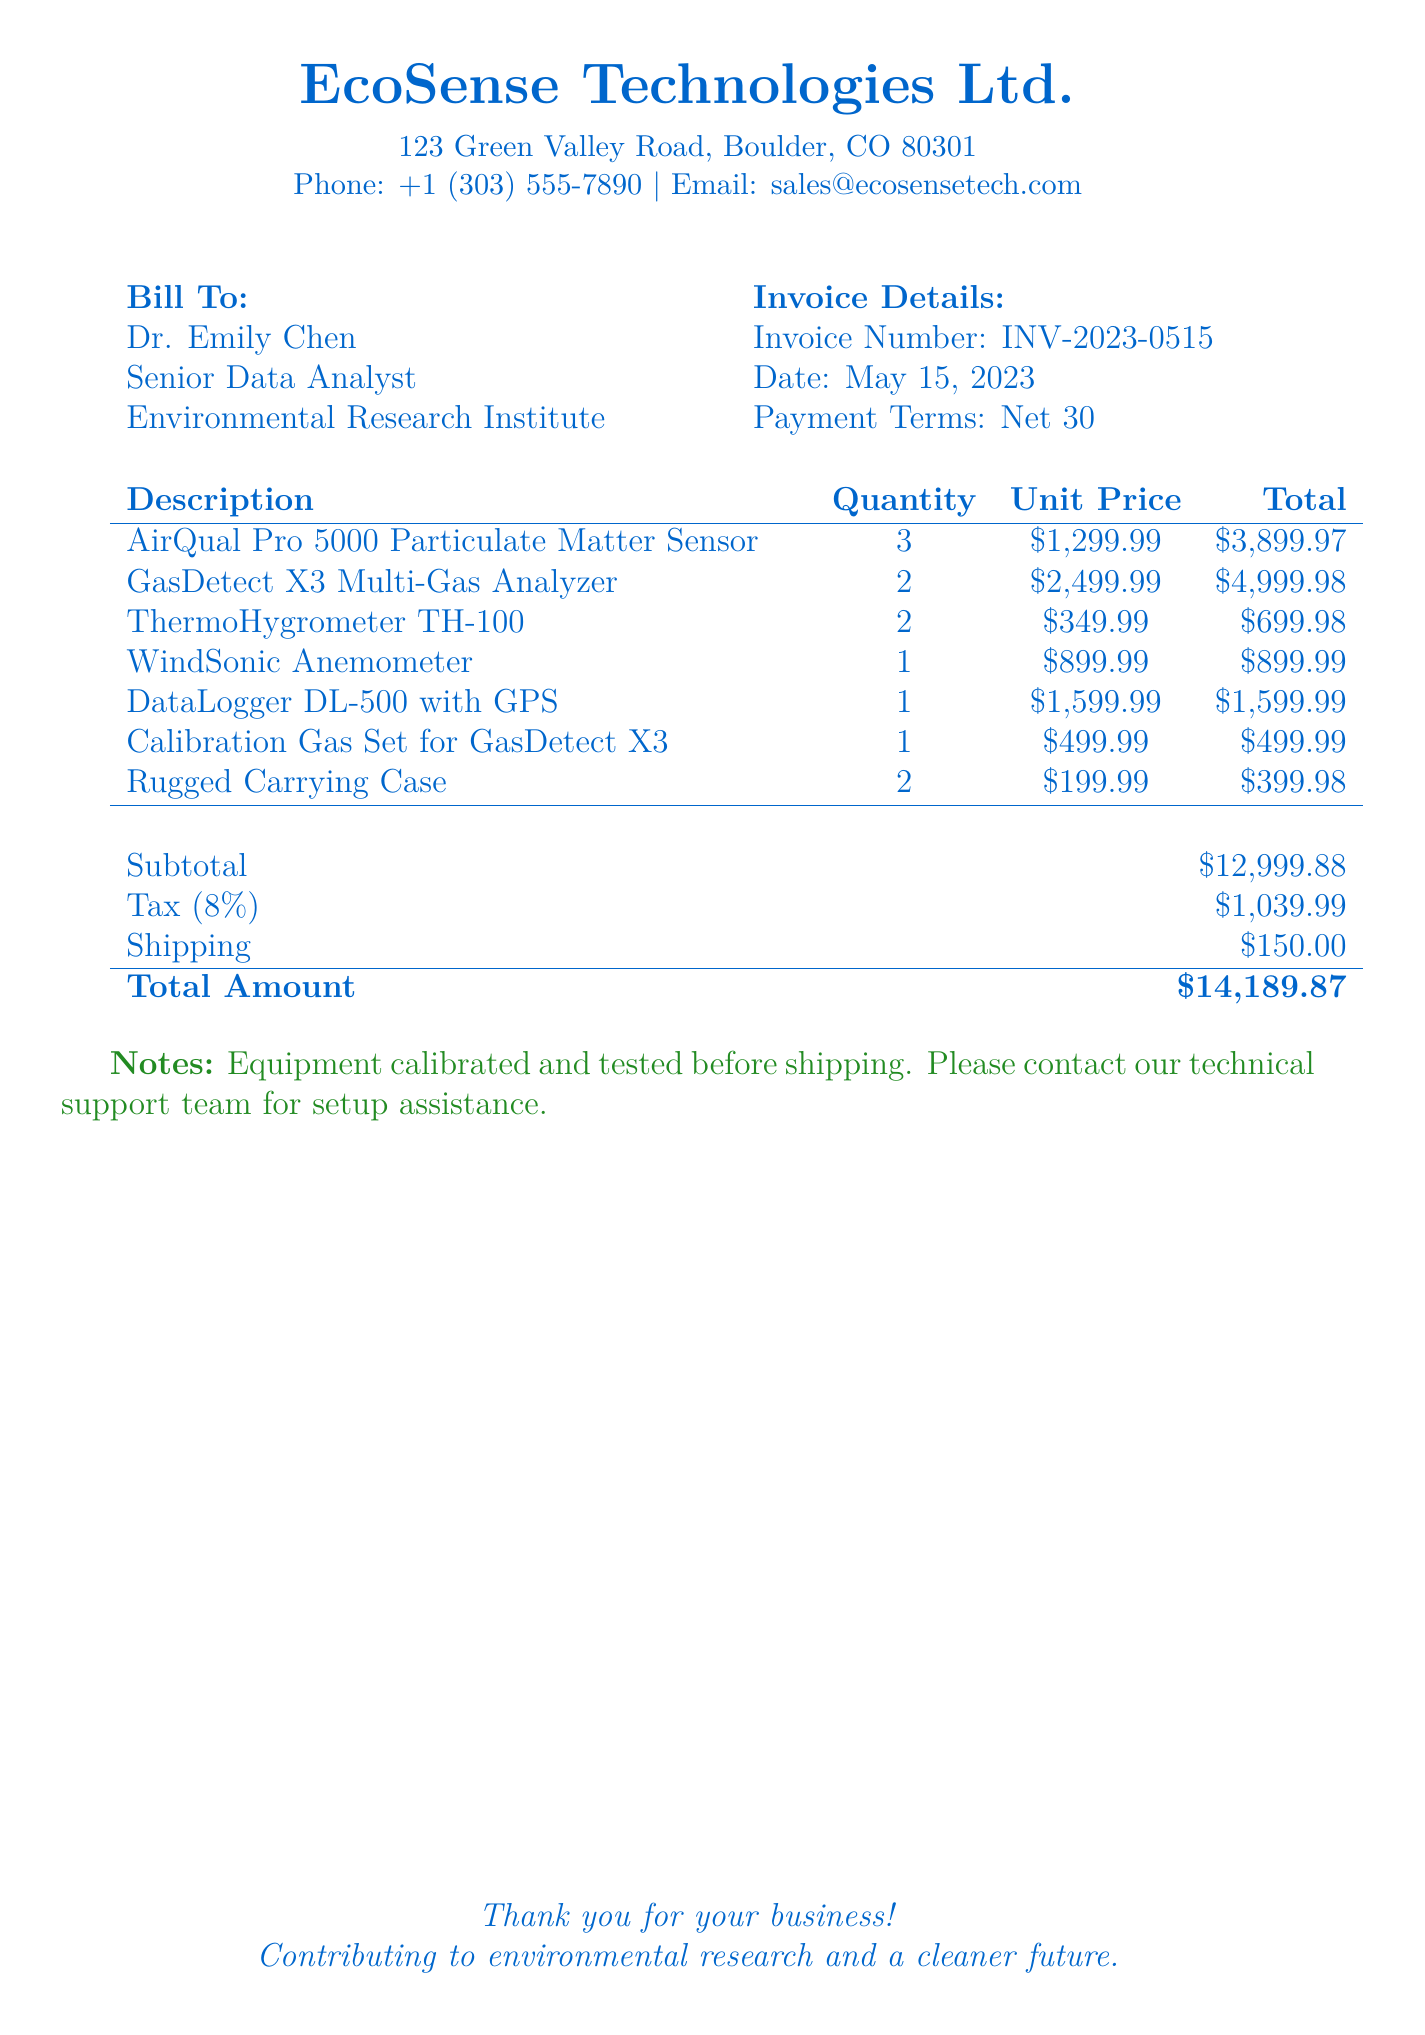What is the invoice number? The invoice number is listed in the Invoice Details section of the document.
Answer: INV-2023-0515 What is the total amount due? The total amount is calculated at the end of the document, including subtotal, tax, and shipping.
Answer: $14,189.87 Who is the biller? The biller is identified in the header section with the company name and contact information.
Answer: EcoSense Technologies Ltd How many AirQual Pro 5000 sensors were purchased? The quantity of AirQual Pro 5000 sensors is specified in the itemized section of the document.
Answer: 3 What is the tax percentage applied? The tax percentage is indicated in the subtotal section of the document.
Answer: 8% What was the shipping cost? The shipping cost is detailed in the subtotal section of the document.
Answer: $150.00 Who is the contact for technical support? The document mentions technical support assistance in the Notes section.
Answer: Technical support team How many items are listed in total? The total number of item entries can be counted in the itemized list.
Answer: 7 What is the unit price of the GasDetect X3 Multi-Gas Analyzer? The unit price is specified in the itemized section of the document for that particular item.
Answer: $2,499.99 